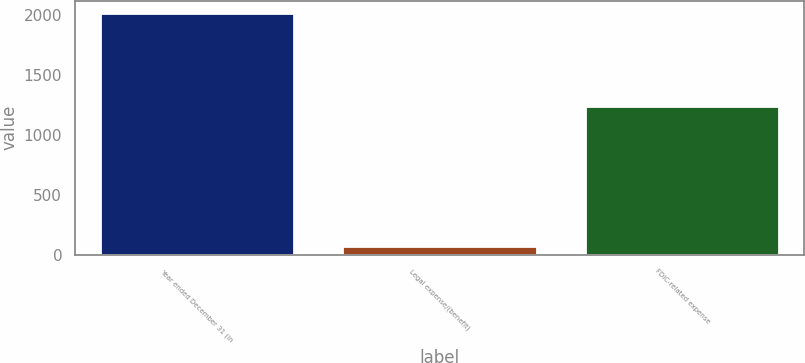Convert chart to OTSL. <chart><loc_0><loc_0><loc_500><loc_500><bar_chart><fcel>Year ended December 31 (in<fcel>Legal expense/(benefit)<fcel>FDIC-related expense<nl><fcel>2018<fcel>72<fcel>1239<nl></chart> 